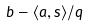Convert formula to latex. <formula><loc_0><loc_0><loc_500><loc_500>b - \langle a , s \rangle / q</formula> 